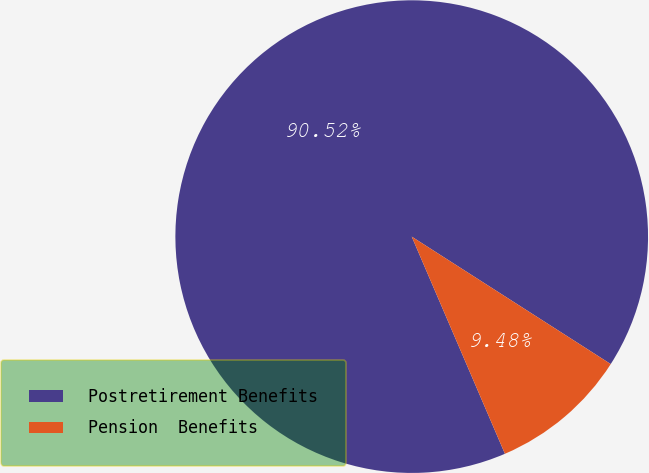Convert chart. <chart><loc_0><loc_0><loc_500><loc_500><pie_chart><fcel>Postretirement Benefits<fcel>Pension  Benefits<nl><fcel>90.52%<fcel>9.48%<nl></chart> 